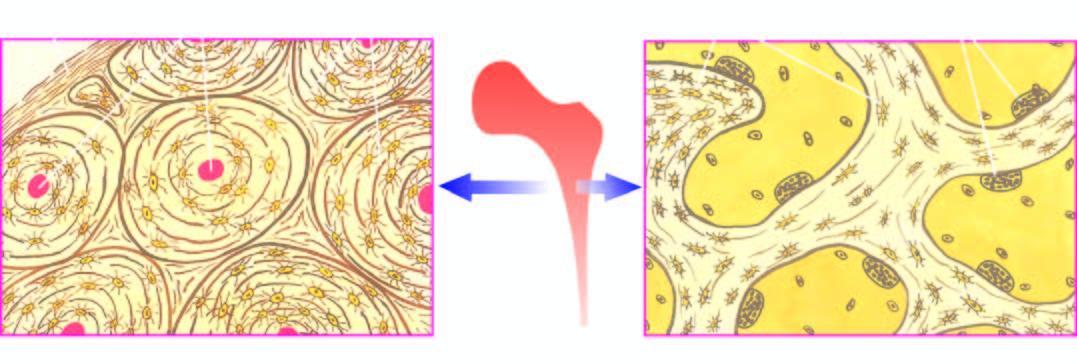what does the cortical bone forming the outer shell show?
Answer the question using a single word or phrase. Concentric lamellae along with osteocytic lacunae surrounding central blood vessels 